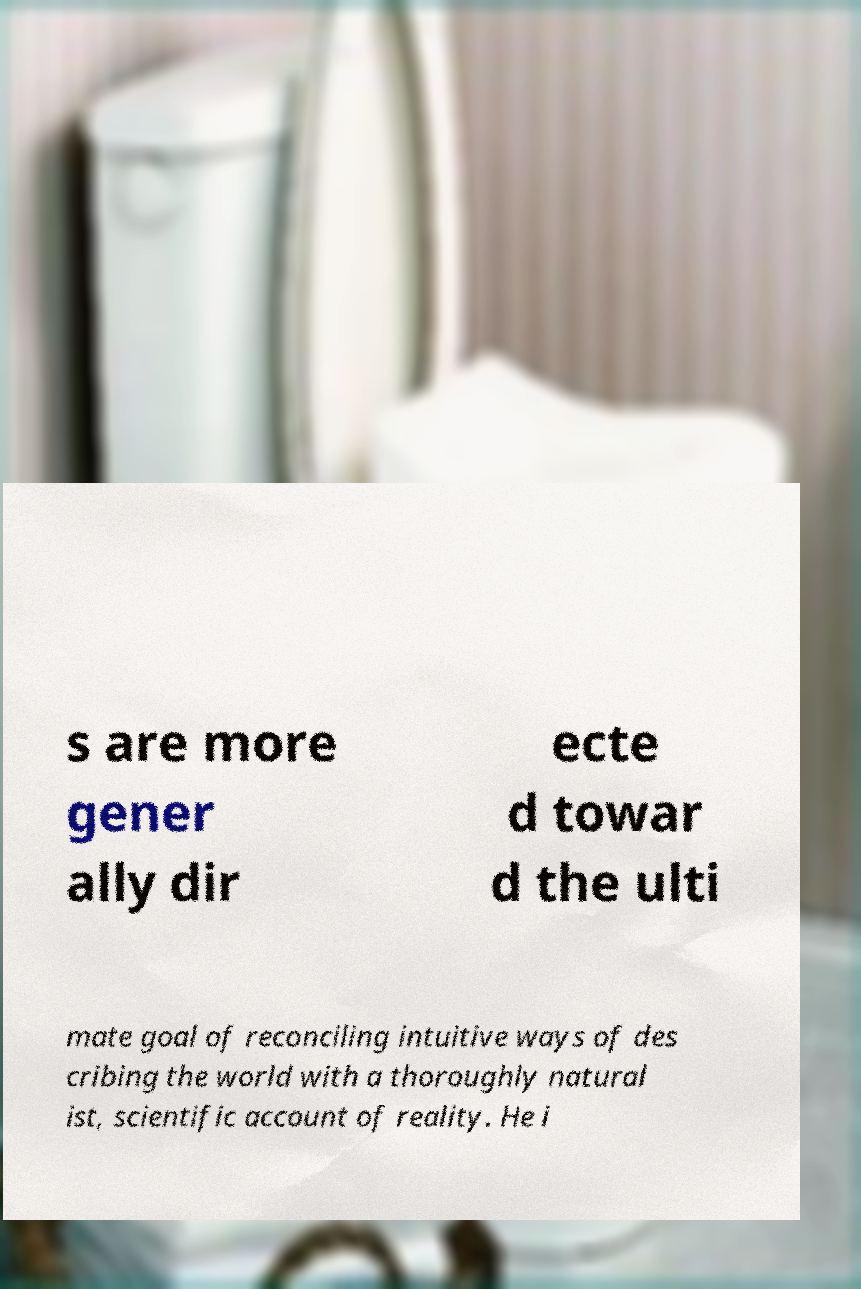There's text embedded in this image that I need extracted. Can you transcribe it verbatim? s are more gener ally dir ecte d towar d the ulti mate goal of reconciling intuitive ways of des cribing the world with a thoroughly natural ist, scientific account of reality. He i 